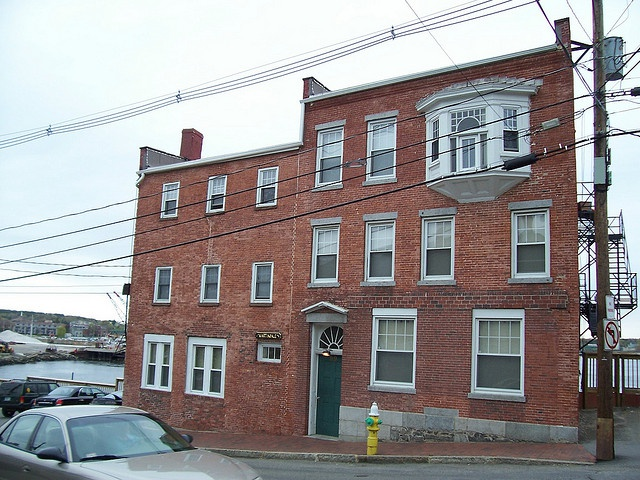Describe the objects in this image and their specific colors. I can see car in lightblue, darkgray, and gray tones, car in lightblue, black, blue, darkblue, and gray tones, car in lightblue, black, and gray tones, and fire hydrant in lightblue, olive, and gray tones in this image. 